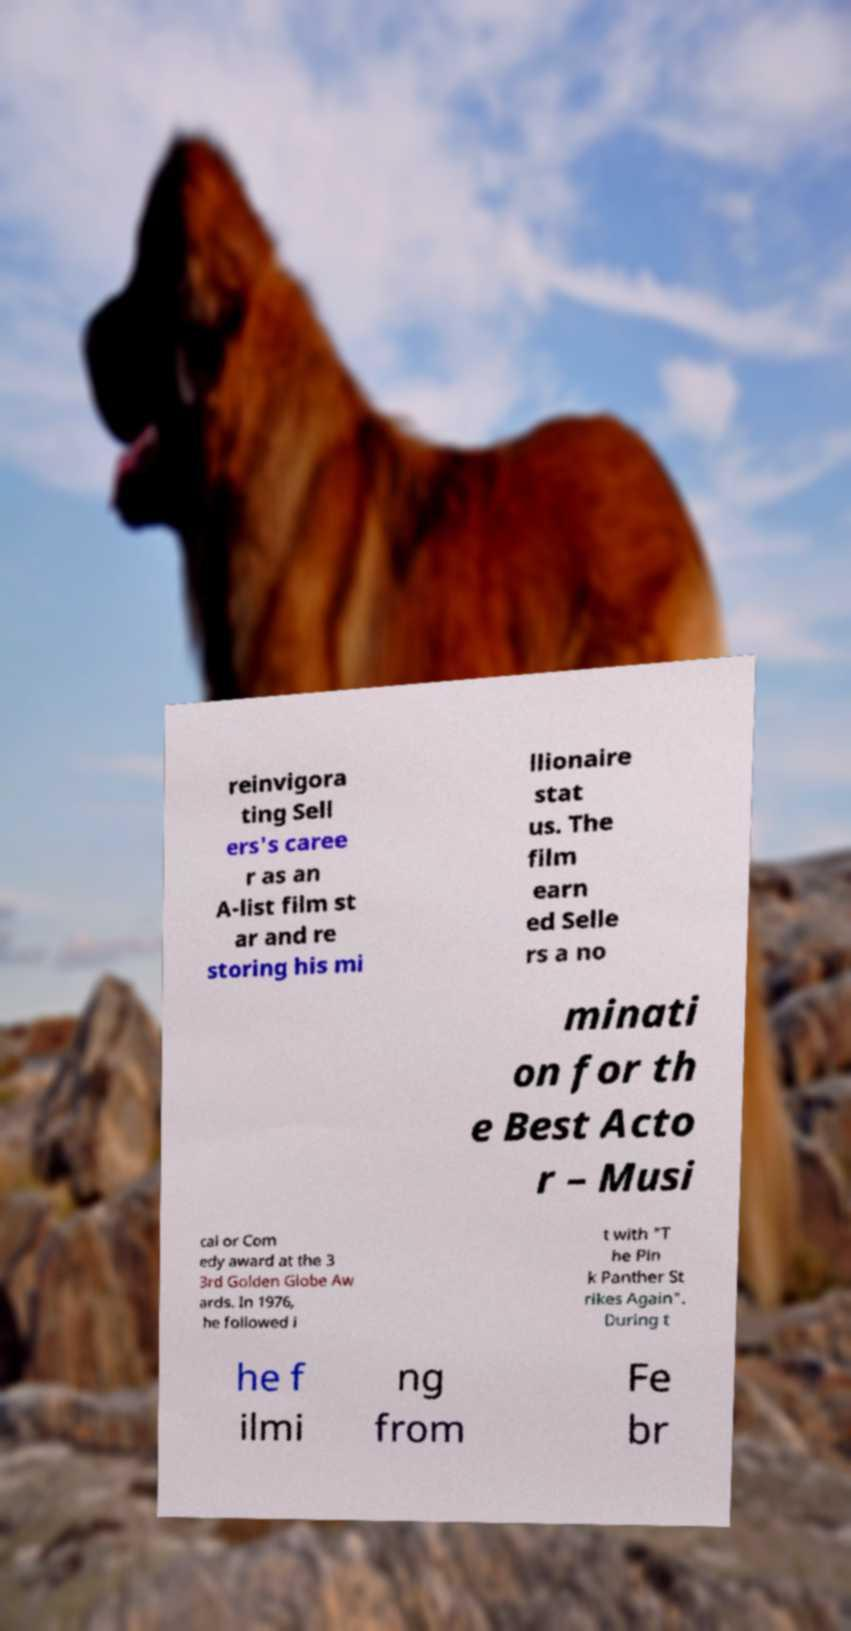Can you accurately transcribe the text from the provided image for me? reinvigora ting Sell ers's caree r as an A-list film st ar and re storing his mi llionaire stat us. The film earn ed Selle rs a no minati on for th e Best Acto r – Musi cal or Com edy award at the 3 3rd Golden Globe Aw ards. In 1976, he followed i t with "T he Pin k Panther St rikes Again". During t he f ilmi ng from Fe br 